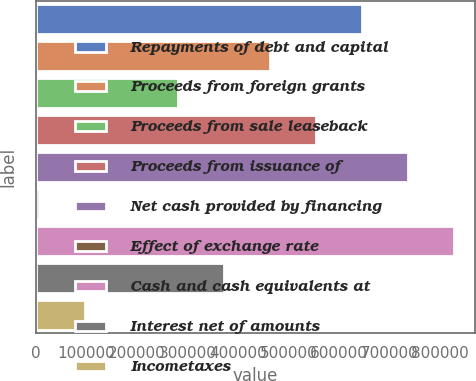Convert chart to OTSL. <chart><loc_0><loc_0><loc_500><loc_500><bar_chart><fcel>Repayments of debt and capital<fcel>Proceeds from foreign grants<fcel>Proceeds from sale leaseback<fcel>Proceeds from issuance of<fcel>Net cash provided by financing<fcel>Effect of exchange rate<fcel>Cash and cash equivalents at<fcel>Interest net of amounts<fcel>Incometaxes<nl><fcel>645032<fcel>462802<fcel>280573<fcel>553917<fcel>736147<fcel>7228<fcel>827262<fcel>371688<fcel>98342.9<nl></chart> 